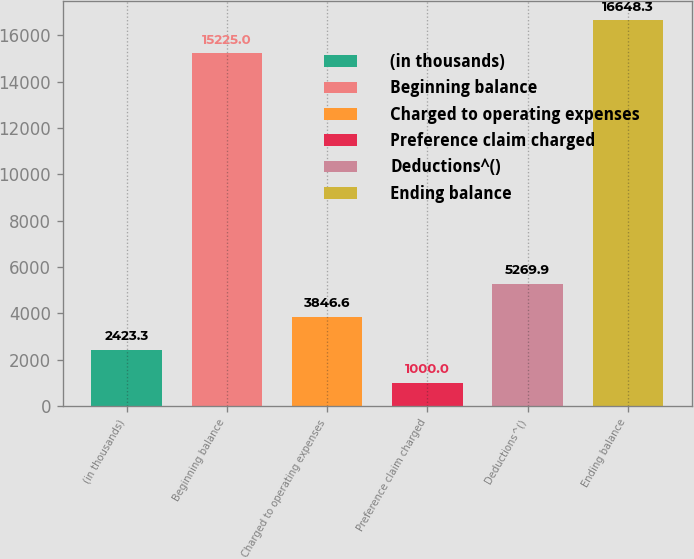<chart> <loc_0><loc_0><loc_500><loc_500><bar_chart><fcel>(in thousands)<fcel>Beginning balance<fcel>Charged to operating expenses<fcel>Preference claim charged<fcel>Deductions^()<fcel>Ending balance<nl><fcel>2423.3<fcel>15225<fcel>3846.6<fcel>1000<fcel>5269.9<fcel>16648.3<nl></chart> 